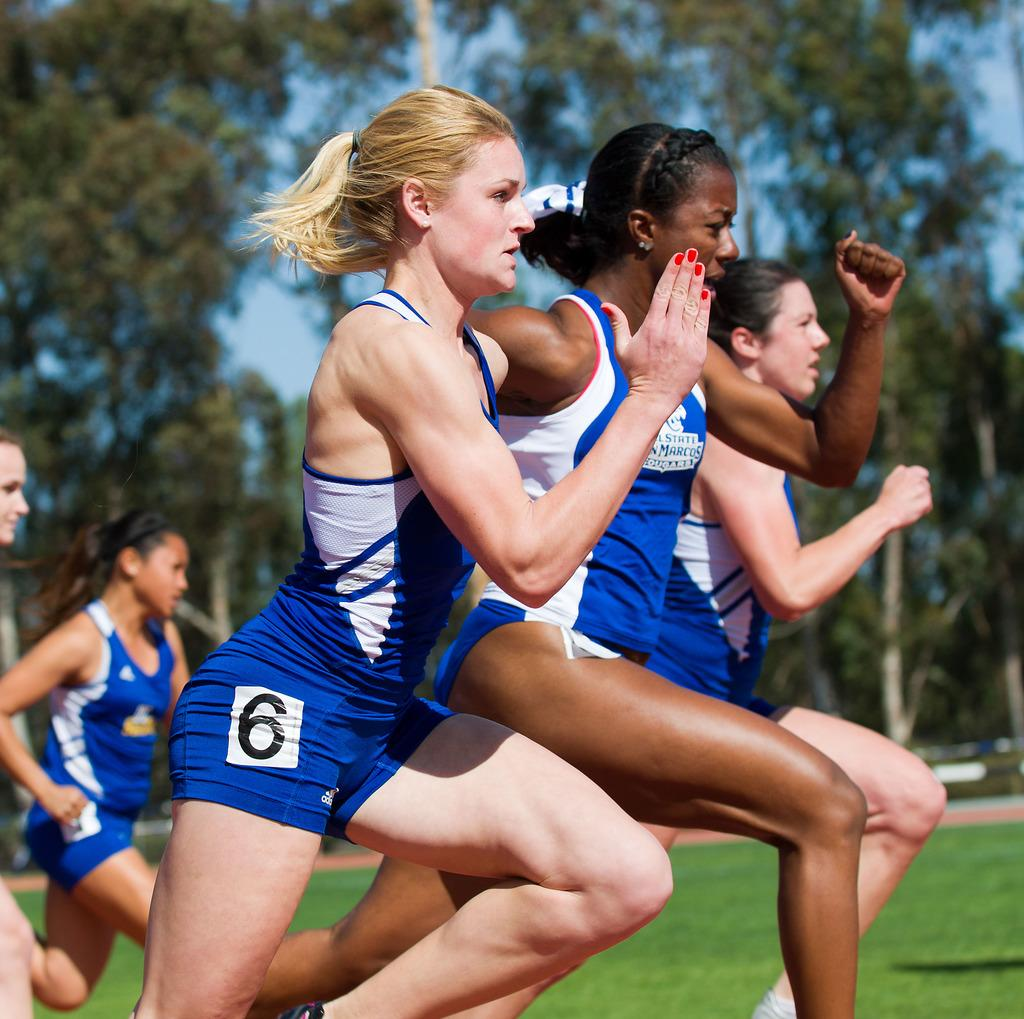<image>
Write a terse but informative summary of the picture. A line of women running a race one is number 6. 